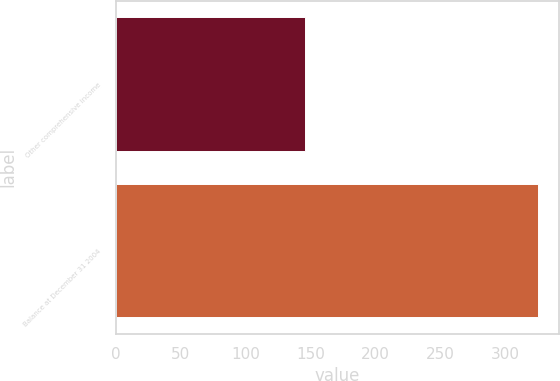Convert chart. <chart><loc_0><loc_0><loc_500><loc_500><bar_chart><fcel>Other comprehensive income<fcel>Balance at December 31 2004<nl><fcel>145.5<fcel>325.2<nl></chart> 